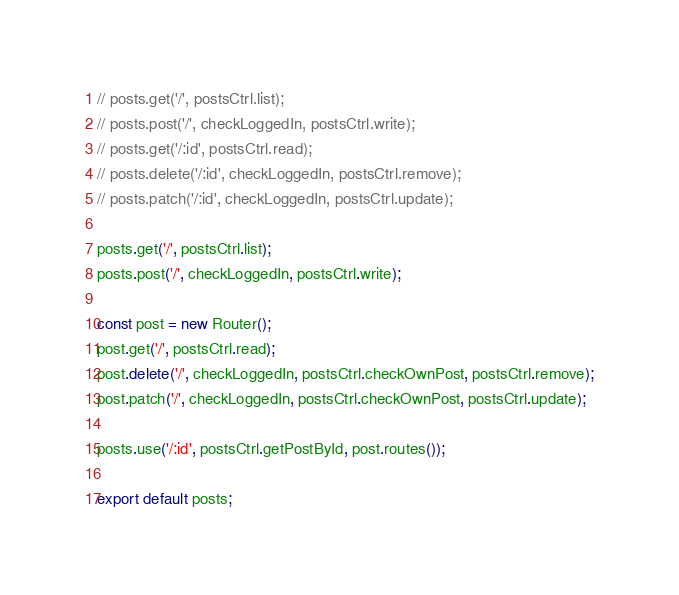<code> <loc_0><loc_0><loc_500><loc_500><_JavaScript_>
// posts.get('/', postsCtrl.list);
// posts.post('/', checkLoggedIn, postsCtrl.write);
// posts.get('/:id', postsCtrl.read);
// posts.delete('/:id', checkLoggedIn, postsCtrl.remove);
// posts.patch('/:id', checkLoggedIn, postsCtrl.update);

posts.get('/', postsCtrl.list);
posts.post('/', checkLoggedIn, postsCtrl.write);

const post = new Router();
post.get('/', postsCtrl.read);
post.delete('/', checkLoggedIn, postsCtrl.checkOwnPost, postsCtrl.remove);
post.patch('/', checkLoggedIn, postsCtrl.checkOwnPost, postsCtrl.update);

posts.use('/:id', postsCtrl.getPostById, post.routes());

export default posts;</code> 